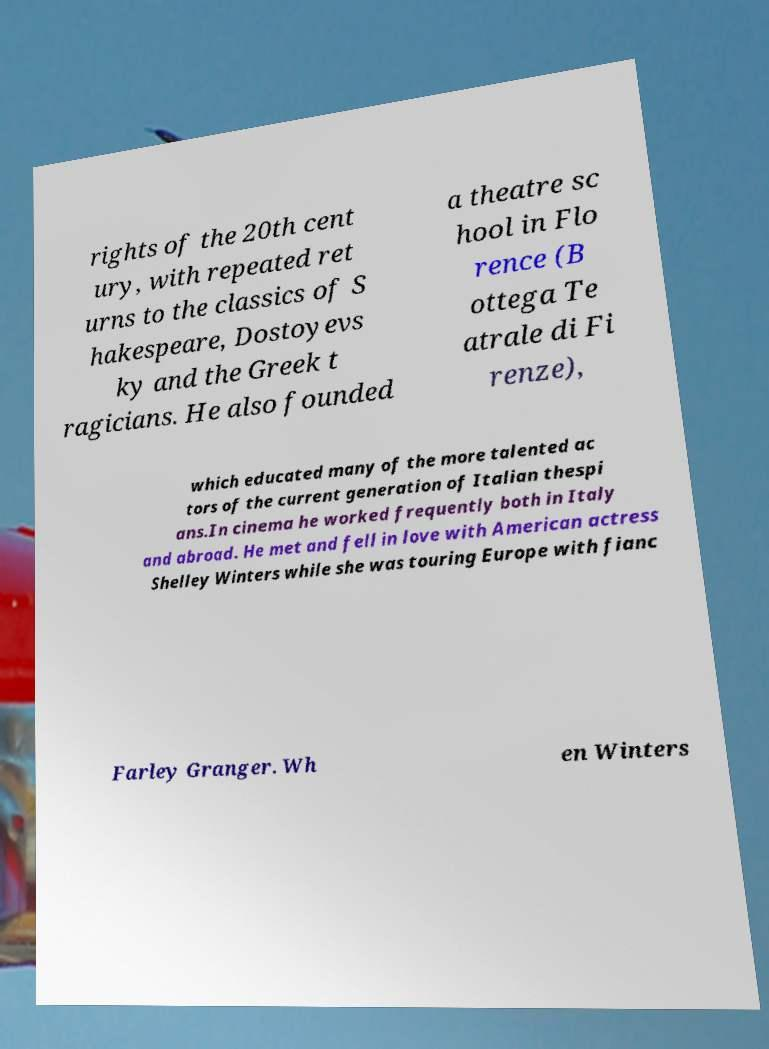Can you accurately transcribe the text from the provided image for me? rights of the 20th cent ury, with repeated ret urns to the classics of S hakespeare, Dostoyevs ky and the Greek t ragicians. He also founded a theatre sc hool in Flo rence (B ottega Te atrale di Fi renze), which educated many of the more talented ac tors of the current generation of Italian thespi ans.In cinema he worked frequently both in Italy and abroad. He met and fell in love with American actress Shelley Winters while she was touring Europe with fianc Farley Granger. Wh en Winters 